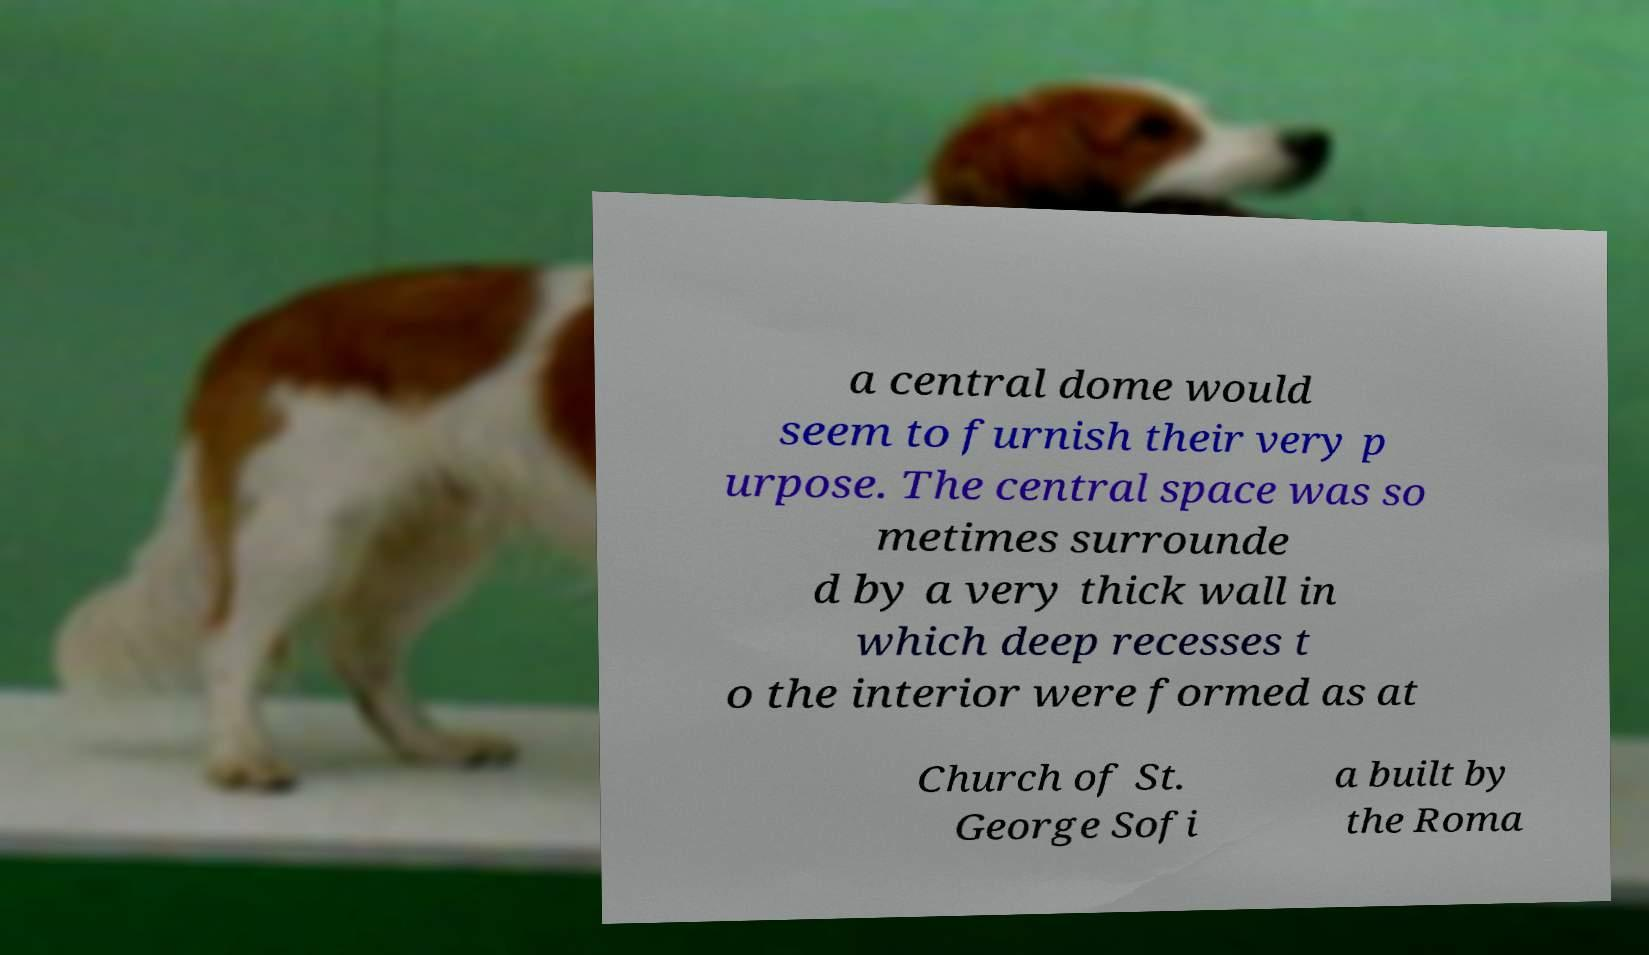Could you assist in decoding the text presented in this image and type it out clearly? a central dome would seem to furnish their very p urpose. The central space was so metimes surrounde d by a very thick wall in which deep recesses t o the interior were formed as at Church of St. George Sofi a built by the Roma 